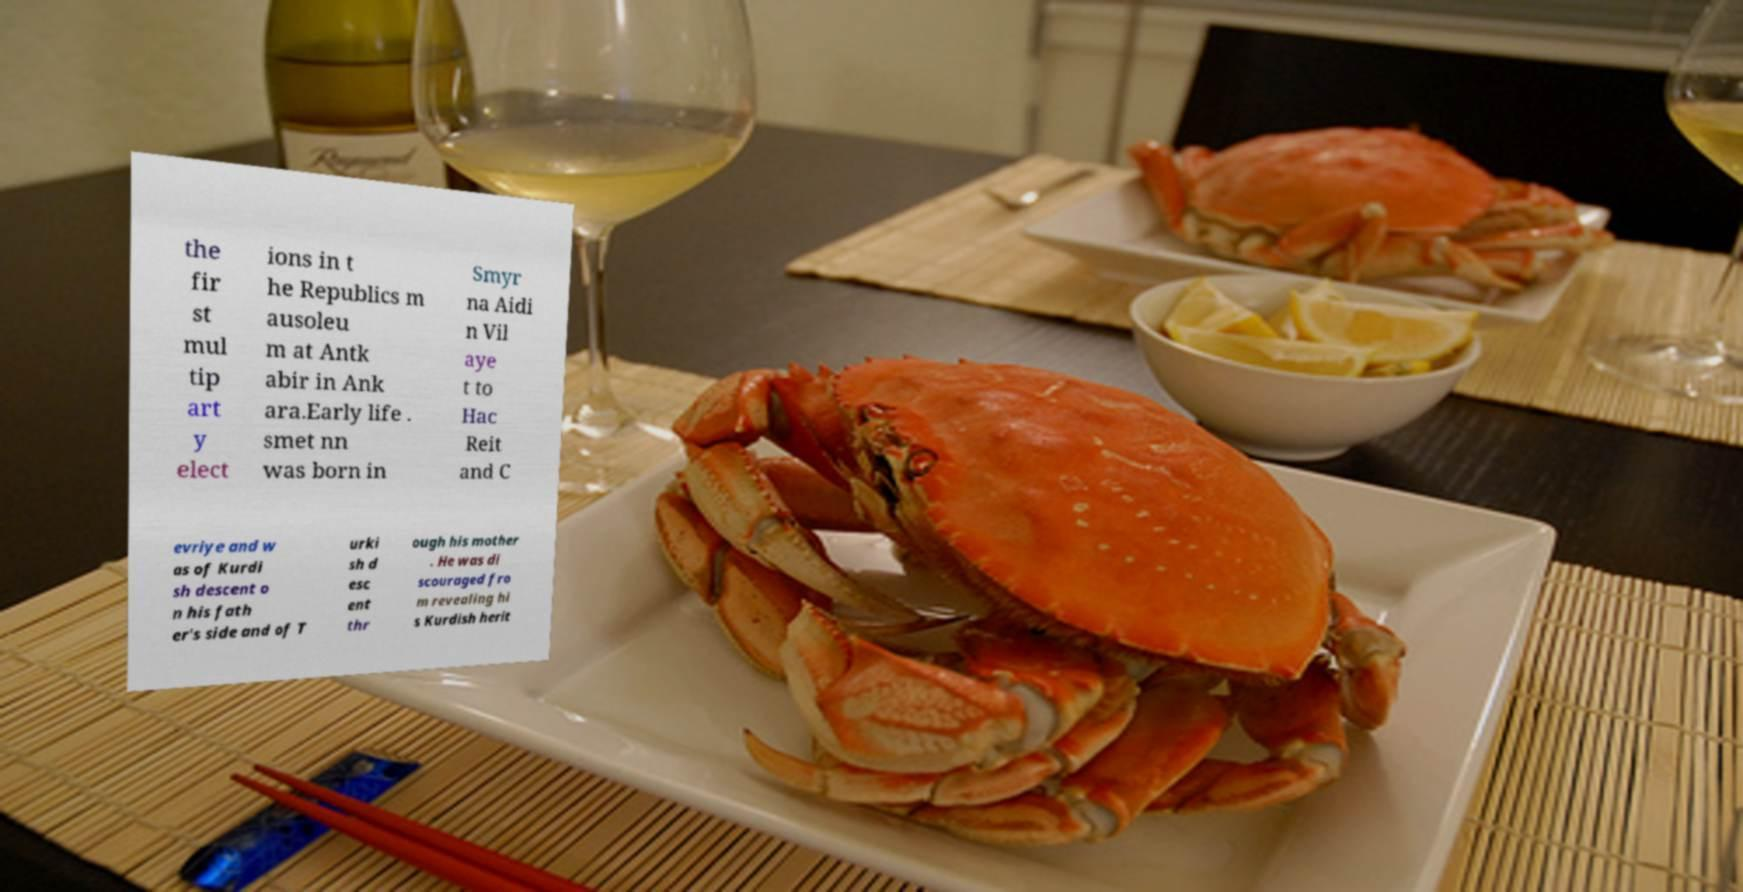Can you read and provide the text displayed in the image?This photo seems to have some interesting text. Can you extract and type it out for me? the fir st mul tip art y elect ions in t he Republics m ausoleu m at Antk abir in Ank ara.Early life . smet nn was born in Smyr na Aidi n Vil aye t to Hac Reit and C evriye and w as of Kurdi sh descent o n his fath er's side and of T urki sh d esc ent thr ough his mother . He was di scouraged fro m revealing hi s Kurdish herit 